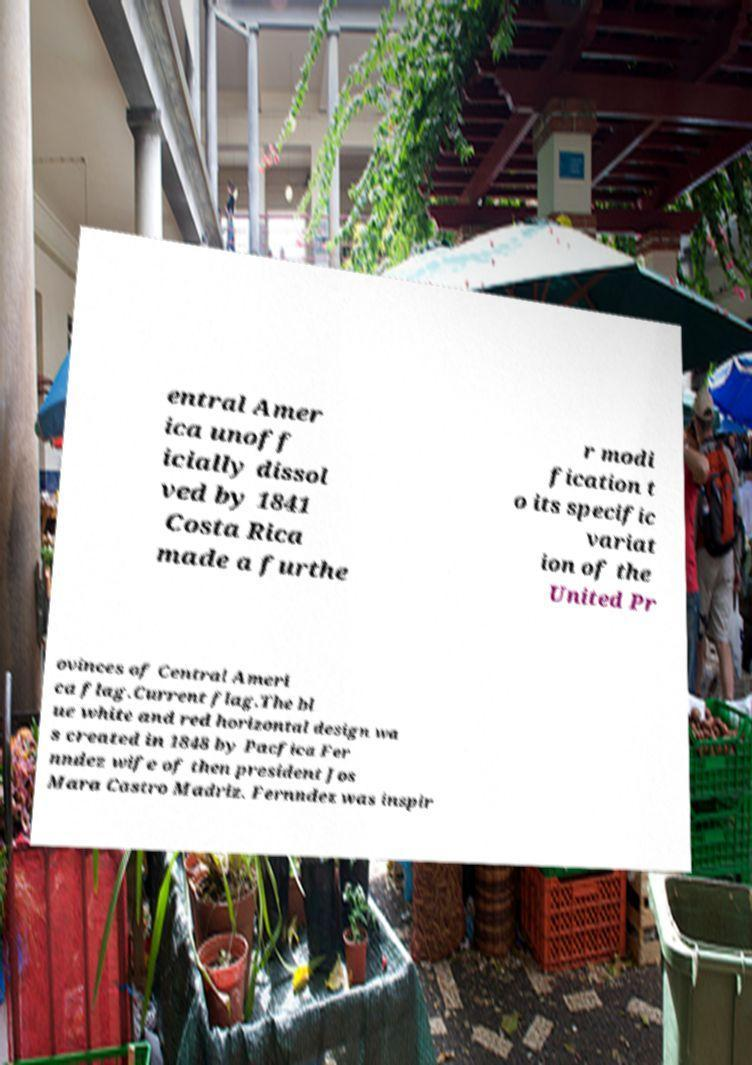Please identify and transcribe the text found in this image. entral Amer ica unoff icially dissol ved by 1841 Costa Rica made a furthe r modi fication t o its specific variat ion of the United Pr ovinces of Central Ameri ca flag.Current flag.The bl ue white and red horizontal design wa s created in 1848 by Pacfica Fer nndez wife of then president Jos Mara Castro Madriz. Fernndez was inspir 